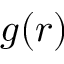Convert formula to latex. <formula><loc_0><loc_0><loc_500><loc_500>g ( r )</formula> 